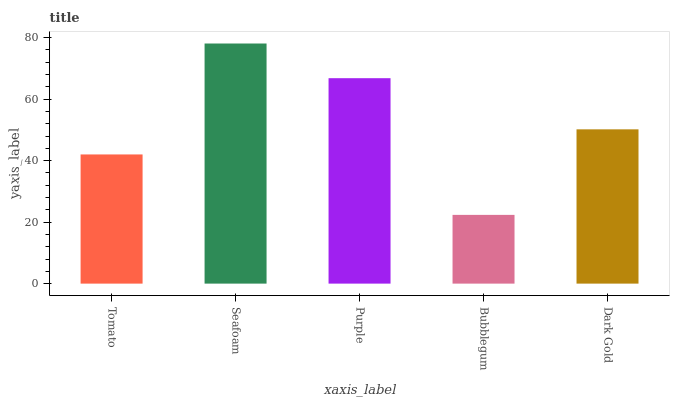Is Bubblegum the minimum?
Answer yes or no. Yes. Is Seafoam the maximum?
Answer yes or no. Yes. Is Purple the minimum?
Answer yes or no. No. Is Purple the maximum?
Answer yes or no. No. Is Seafoam greater than Purple?
Answer yes or no. Yes. Is Purple less than Seafoam?
Answer yes or no. Yes. Is Purple greater than Seafoam?
Answer yes or no. No. Is Seafoam less than Purple?
Answer yes or no. No. Is Dark Gold the high median?
Answer yes or no. Yes. Is Dark Gold the low median?
Answer yes or no. Yes. Is Tomato the high median?
Answer yes or no. No. Is Purple the low median?
Answer yes or no. No. 